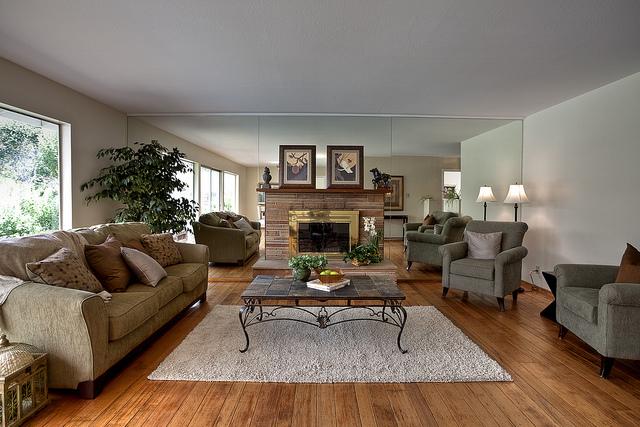What room is this?
Concise answer only. Living room. What Color is the carpet?
Give a very brief answer. White. How many places to sit are in the image?
Short answer required. 5. What is the back wall made of?
Write a very short answer. Mirror. 